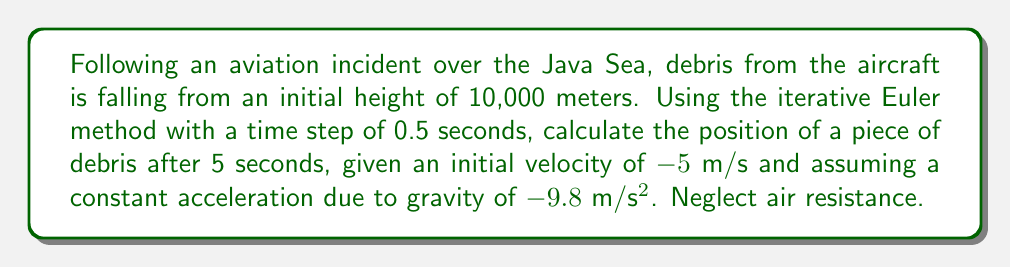Could you help me with this problem? To solve this problem, we'll use the Euler method, an iterative numerical method for solving ordinary differential equations. The method updates the position and velocity at each time step.

Given:
- Initial height $h_0 = 10000$ m
- Initial velocity $v_0 = -5$ m/s
- Acceleration $a = -9.8$ m/s²
- Time step $\Delta t = 0.5$ s
- Total time $t = 5$ s

The Euler method equations are:
$$v_{i+1} = v_i + a \cdot \Delta t$$
$$h_{i+1} = h_i + v_i \cdot \Delta t$$

Let's iterate through the steps:

Step 0 (t = 0 s):
$h_0 = 10000$ m, $v_0 = -5$ m/s

Step 1 (t = 0.5 s):
$v_1 = -5 + (-9.8 \cdot 0.5) = -9.9$ m/s
$h_1 = 10000 + (-5 \cdot 0.5) = 9997.5$ m

Step 2 (t = 1.0 s):
$v_2 = -9.9 + (-9.8 \cdot 0.5) = -14.8$ m/s
$h_2 = 9997.5 + (-9.9 \cdot 0.5) = 9992.55$ m

Step 3 (t = 1.5 s):
$v_3 = -14.8 + (-9.8 \cdot 0.5) = -19.7$ m/s
$h_3 = 9992.55 + (-14.8 \cdot 0.5) = 9985.15$ m

Step 4 (t = 2.0 s):
$v_4 = -19.7 + (-9.8 \cdot 0.5) = -24.6$ m/s
$h_4 = 9985.15 + (-19.7 \cdot 0.5) = 9975.3$ m

Step 5 (t = 2.5 s):
$v_5 = -24.6 + (-9.8 \cdot 0.5) = -29.5$ m/s
$h_5 = 9975.3 + (-24.6 \cdot 0.5) = 9963.0$ m

Step 6 (t = 3.0 s):
$v_6 = -29.5 + (-9.8 \cdot 0.5) = -34.4$ m/s
$h_6 = 9963.0 + (-29.5 \cdot 0.5) = 9948.25$ m

Step 7 (t = 3.5 s):
$v_7 = -34.4 + (-9.8 \cdot 0.5) = -39.3$ m/s
$h_7 = 9948.25 + (-34.4 \cdot 0.5) = 9931.05$ m

Step 8 (t = 4.0 s):
$v_8 = -39.3 + (-9.8 \cdot 0.5) = -44.2$ m/s
$h_8 = 9931.05 + (-39.3 \cdot 0.5) = 9911.4$ m

Step 9 (t = 4.5 s):
$v_9 = -44.2 + (-9.8 \cdot 0.5) = -49.1$ m/s
$h_9 = 9911.4 + (-44.2 \cdot 0.5) = 9889.3$ m

Step 10 (t = 5.0 s):
$v_{10} = -49.1 + (-9.8 \cdot 0.5) = -54.0$ m/s
$h_{10} = 9889.3 + (-49.1 \cdot 0.5) = 9864.75$ m

After 5 seconds, the debris is at a height of 9864.75 meters.
Answer: 9864.75 m 